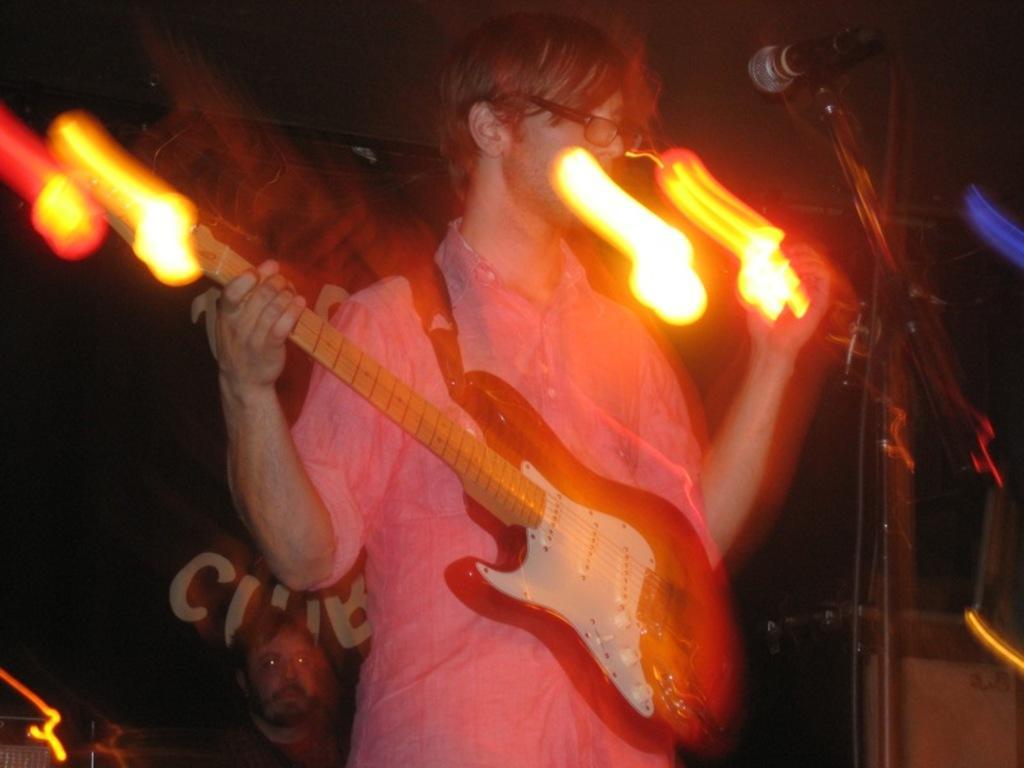Could you give a brief overview of what you see in this image? In this image a person is holding a guitar. He is wearing spectacles. Before him there is a mike stand. Bottom of image there is a person. 